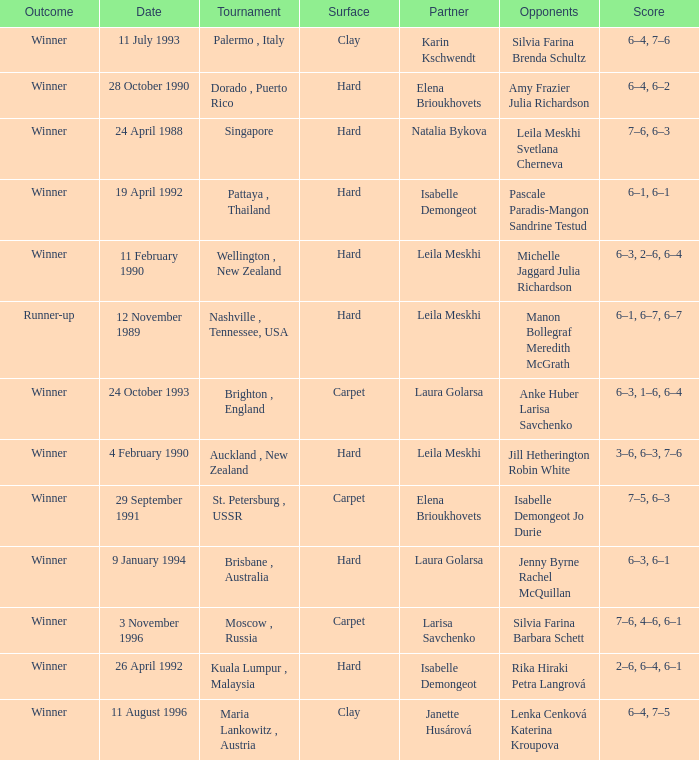In what Tournament was the Score of 3–6, 6–3, 7–6 in a match played on a hard Surface? Auckland , New Zealand. 